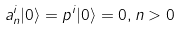<formula> <loc_0><loc_0><loc_500><loc_500>a ^ { i } _ { n } | 0 \rangle = p ^ { i } | 0 \rangle = 0 , n > 0</formula> 